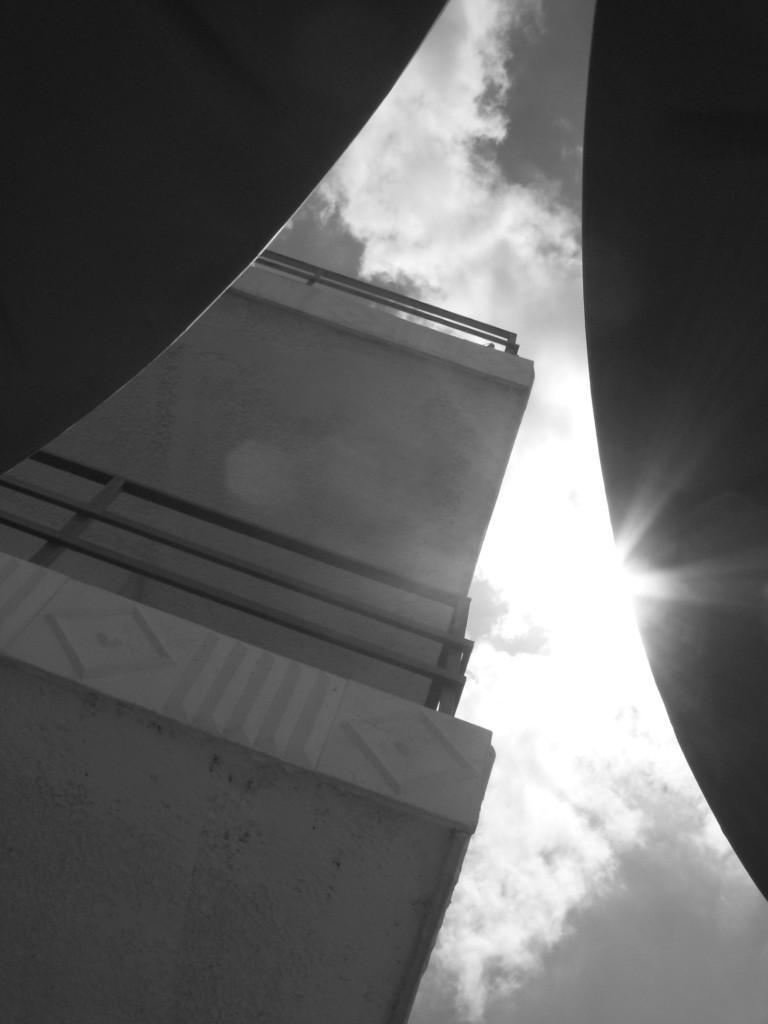Could you give a brief overview of what you see in this image? In this picture we can see a building's, there is the sky at the top of the picture, we can see railing here. 